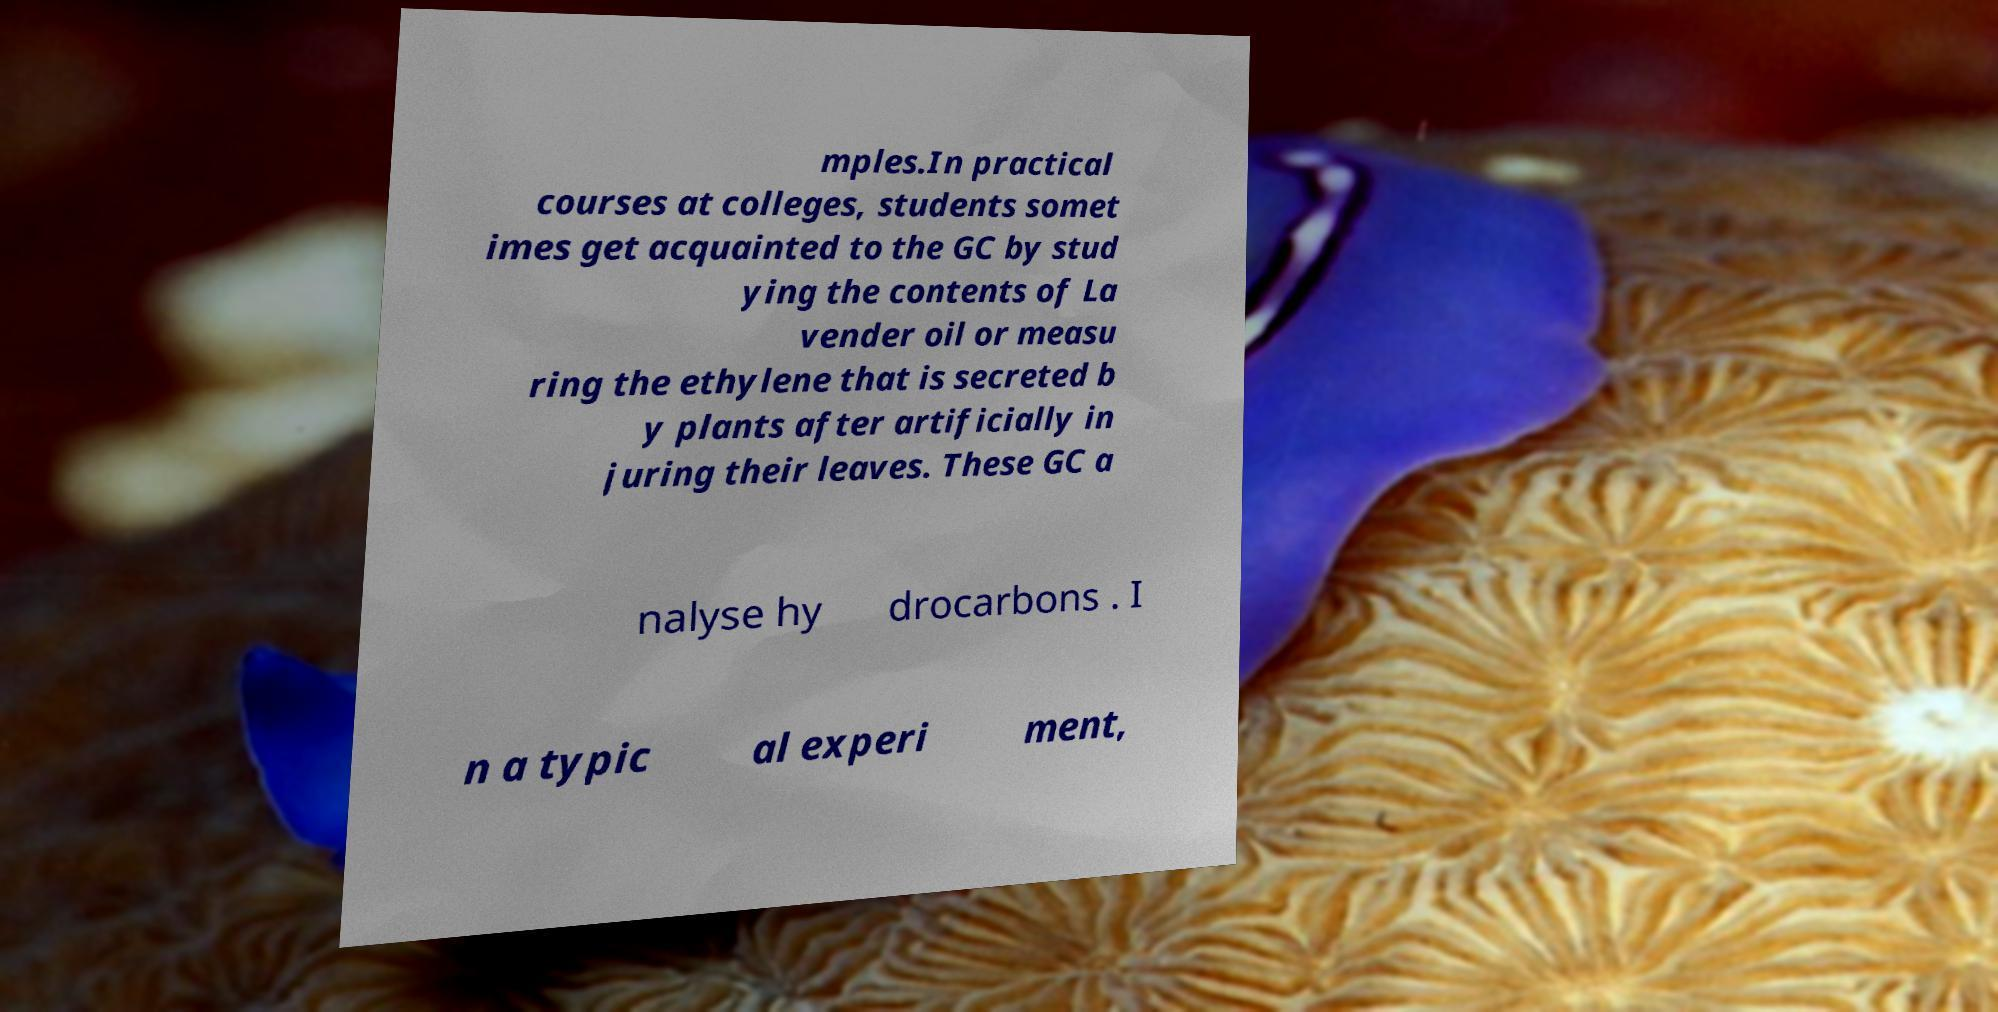What messages or text are displayed in this image? I need them in a readable, typed format. mples.In practical courses at colleges, students somet imes get acquainted to the GC by stud ying the contents of La vender oil or measu ring the ethylene that is secreted b y plants after artificially in juring their leaves. These GC a nalyse hy drocarbons . I n a typic al experi ment, 